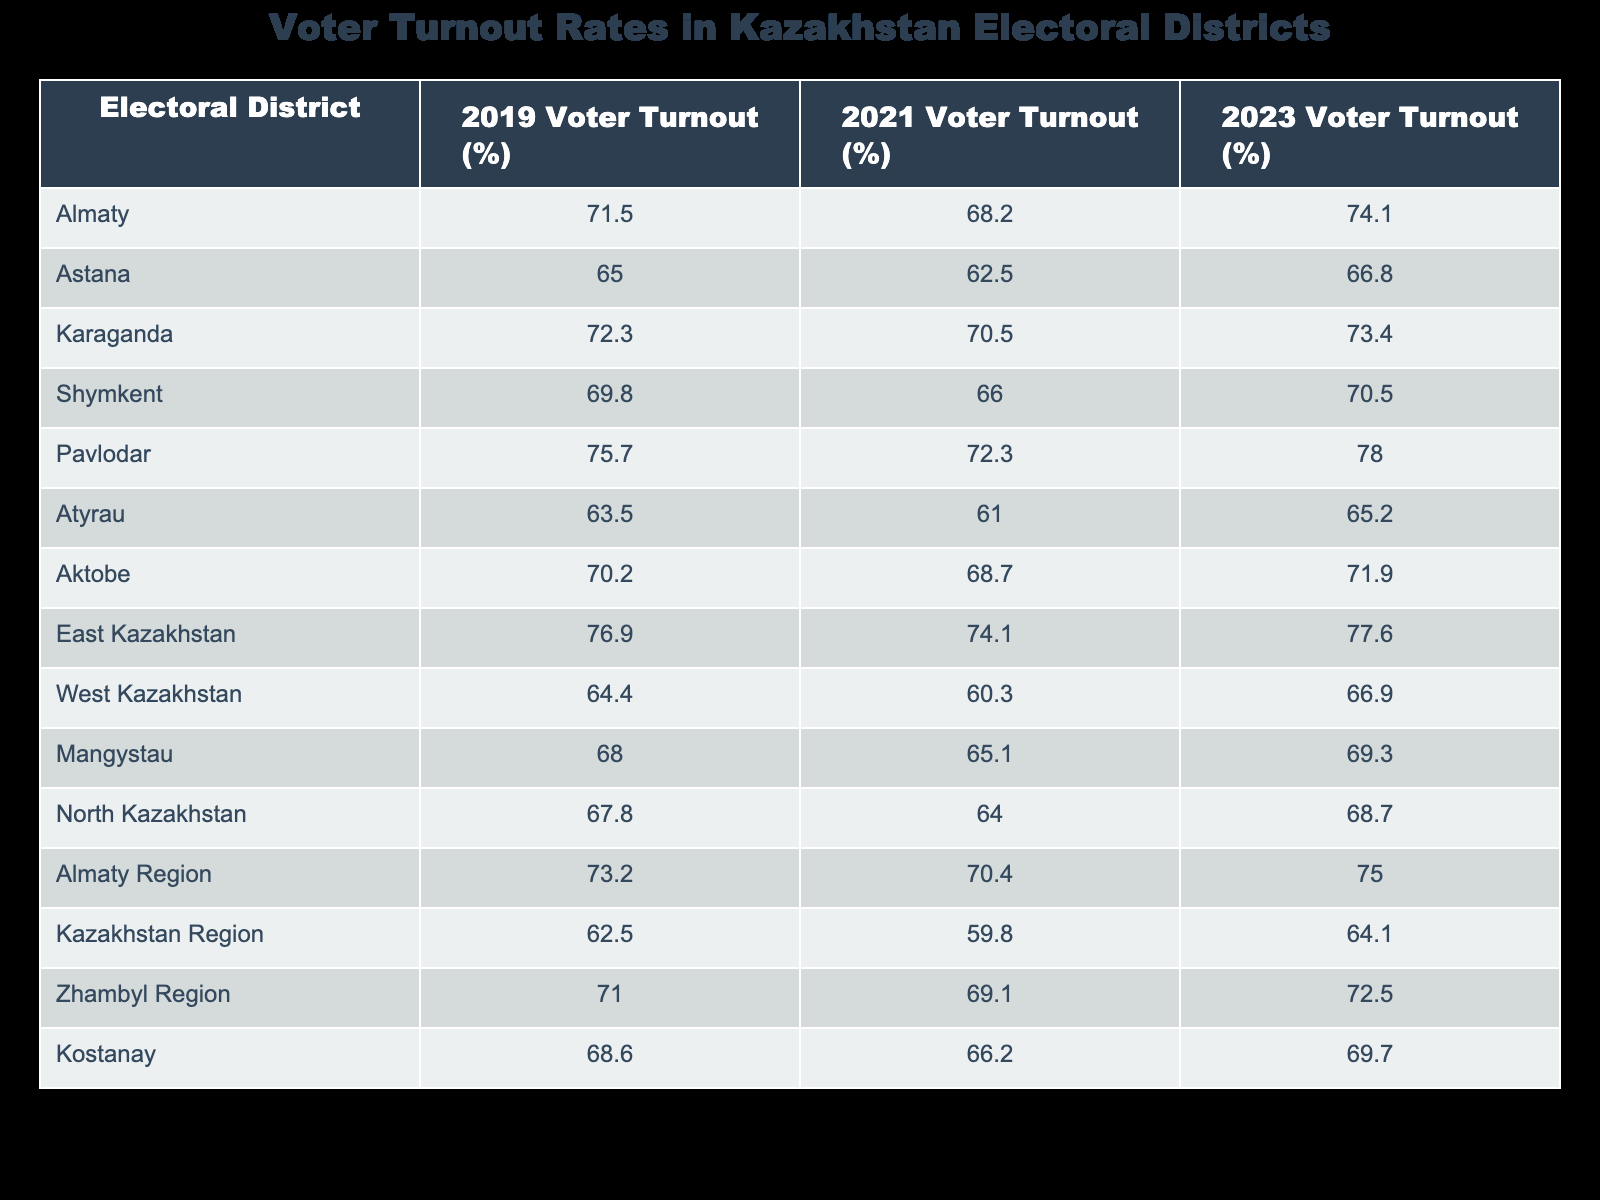What was the voter turnout in Almaty for the 2023 election? The table indicates that Almaty's voter turnout for the 2023 election was 74.1%.
Answer: 74.1% Which electoral district had the lowest voter turnout in 2021? By inspecting the 2021 column, West Kazakhstan shows the lowest percentage at 60.3%.
Answer: West Kazakhstan What is the difference in voter turnout in Pavlodar between the 2019 and 2023 elections? The 2019 turnout was 75.7% and the 2023 turnout is 78.0%. The difference is calculated by subtracting: 78.0 - 75.7 = 2.3%.
Answer: 2.3% Did the voter turnout in Shymkent improve from 2021 to 2023? In 2021, Shymkent's turnout was 66.0%, and in 2023 it was 70.5%. Since 70.5% is greater than 66.0%, it improved.
Answer: Yes What is the average voter turnout for the 2019 elections across all electoral districts? To find the average, add the 2019 percentages (71.5 + 65.0 + 72.3 + 69.8 + 75.7 + 63.5 + 70.2 + 76.9 + 64.4 + 68.0 + 67.8 + 73.2 + 62.5 + 71.0 + 68.6 = 1060.5) and divide by the number of districts (15): 1060.5 / 15 = 70.7%.
Answer: 70.7% Which region had a higher voter turnout in 2023, Atyrau or North Kazakhstan? Atyrau's 2023 turnout is 65.2%, while North Kazakhstan's is 68.7%. Since 68.7% is greater than 65.2%, North Kazakhstan had a higher turnout.
Answer: North Kazakhstan 